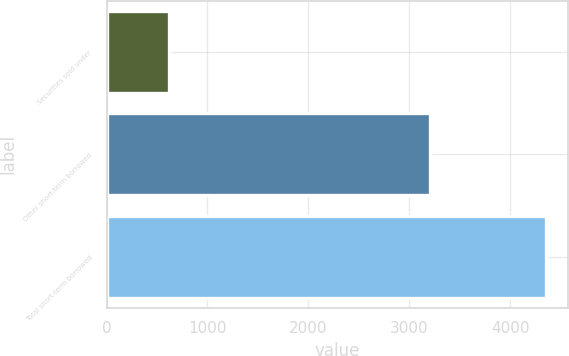Convert chart to OTSL. <chart><loc_0><loc_0><loc_500><loc_500><bar_chart><fcel>Securities sold under<fcel>Other short-term borrowed<fcel>Total short-term borrowed<nl><fcel>615<fcel>3211<fcel>4359<nl></chart> 